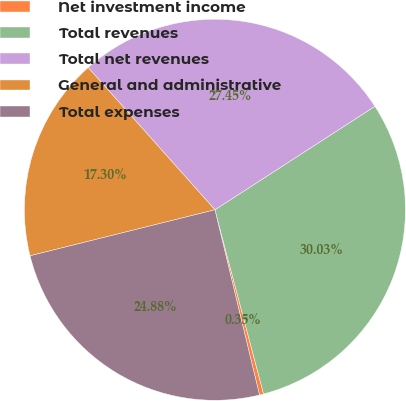Convert chart to OTSL. <chart><loc_0><loc_0><loc_500><loc_500><pie_chart><fcel>Net investment income<fcel>Total revenues<fcel>Total net revenues<fcel>General and administrative<fcel>Total expenses<nl><fcel>0.35%<fcel>30.03%<fcel>27.45%<fcel>17.3%<fcel>24.88%<nl></chart> 